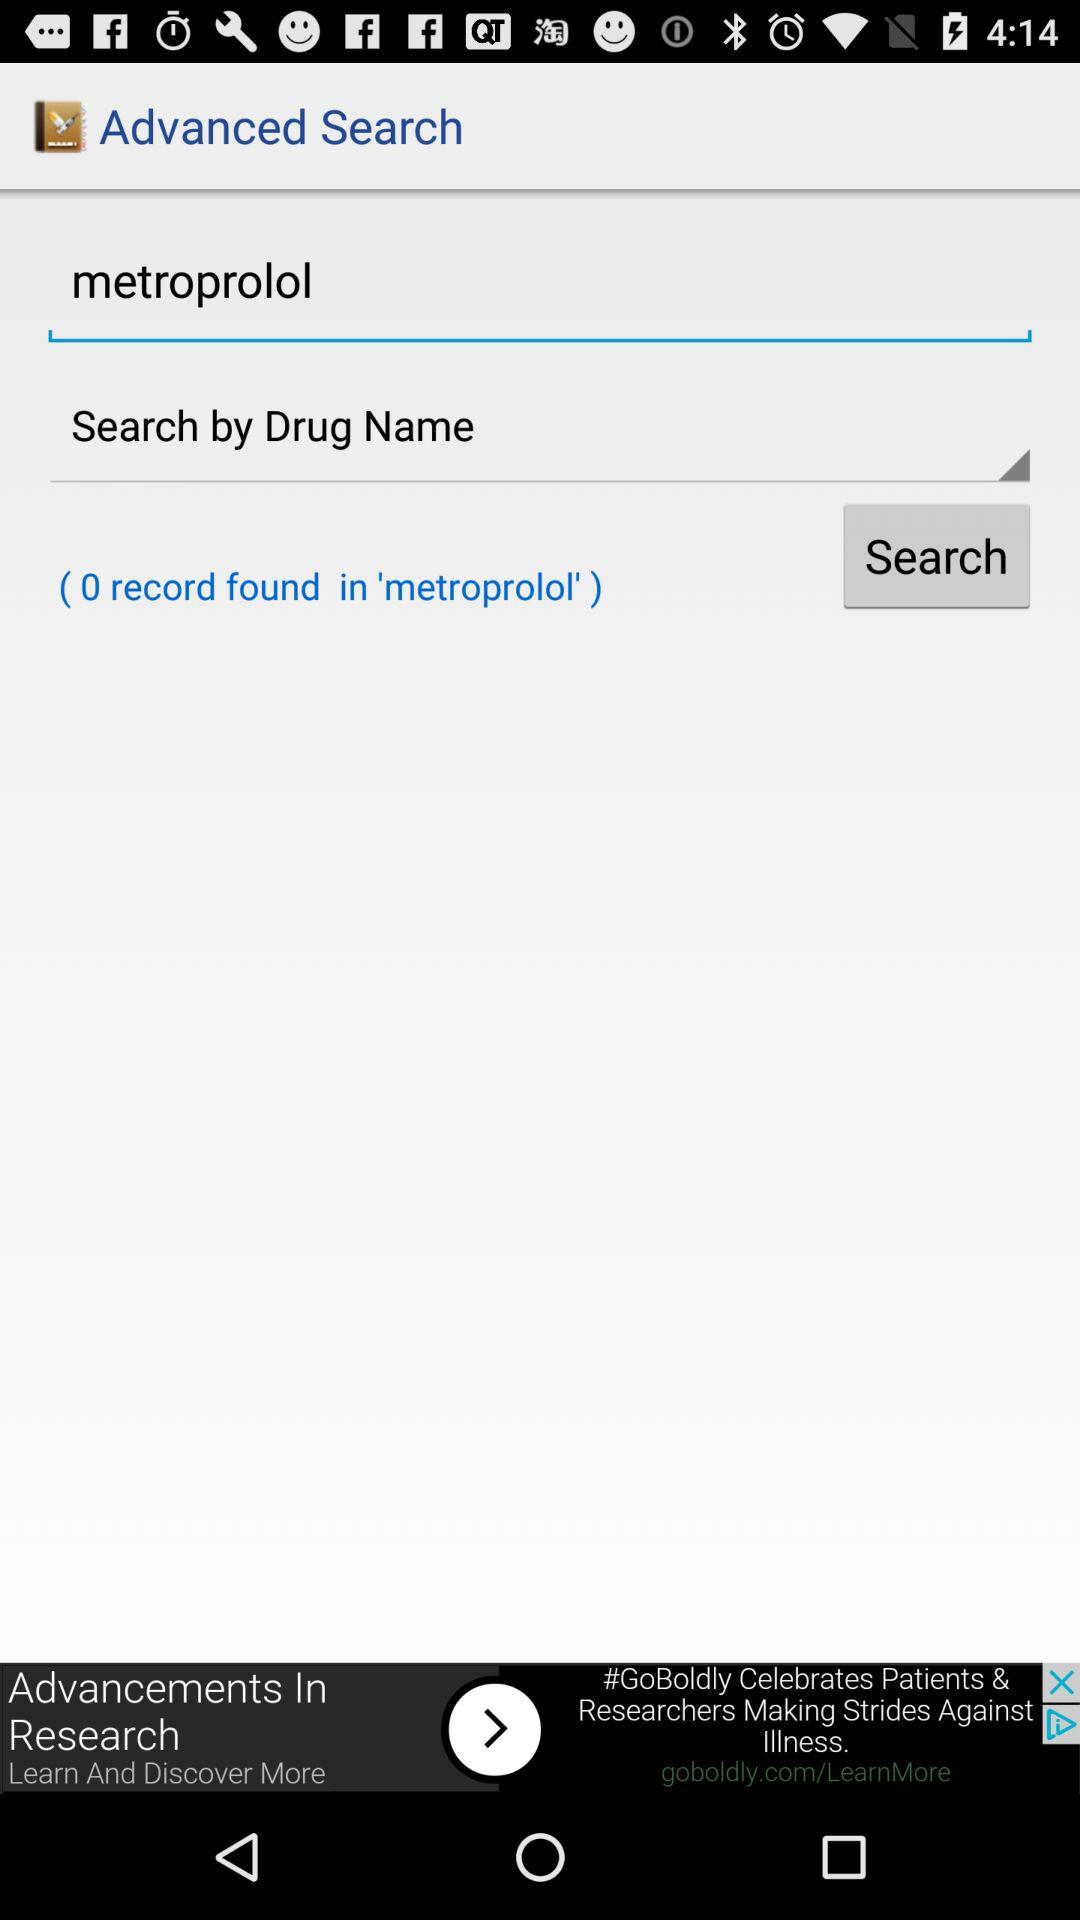How many records were found? There were 0 records found. 